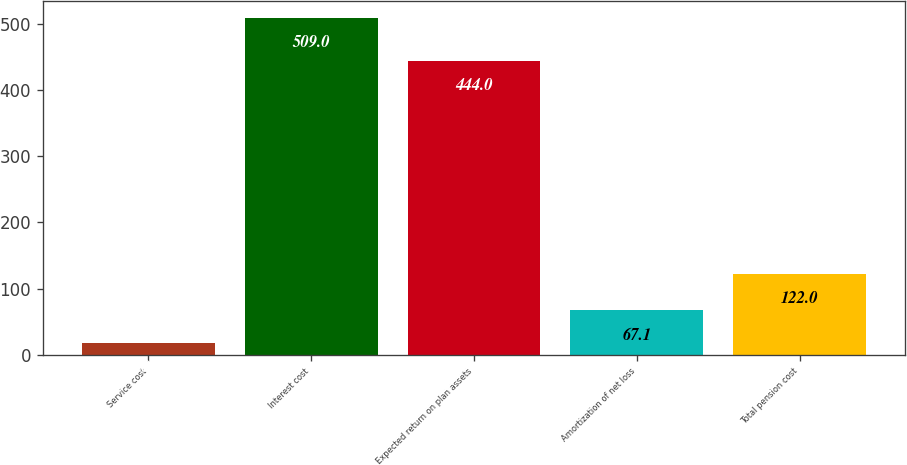Convert chart to OTSL. <chart><loc_0><loc_0><loc_500><loc_500><bar_chart><fcel>Service cost<fcel>Interest cost<fcel>Expected return on plan assets<fcel>Amortization of net loss<fcel>Total pension cost<nl><fcel>18<fcel>509<fcel>444<fcel>67.1<fcel>122<nl></chart> 